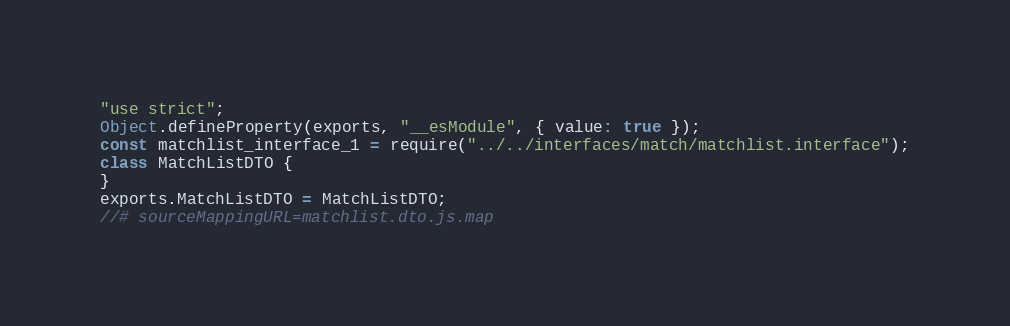Convert code to text. <code><loc_0><loc_0><loc_500><loc_500><_JavaScript_>"use strict";
Object.defineProperty(exports, "__esModule", { value: true });
const matchlist_interface_1 = require("../../interfaces/match/matchlist.interface");
class MatchListDTO {
}
exports.MatchListDTO = MatchListDTO;
//# sourceMappingURL=matchlist.dto.js.map</code> 